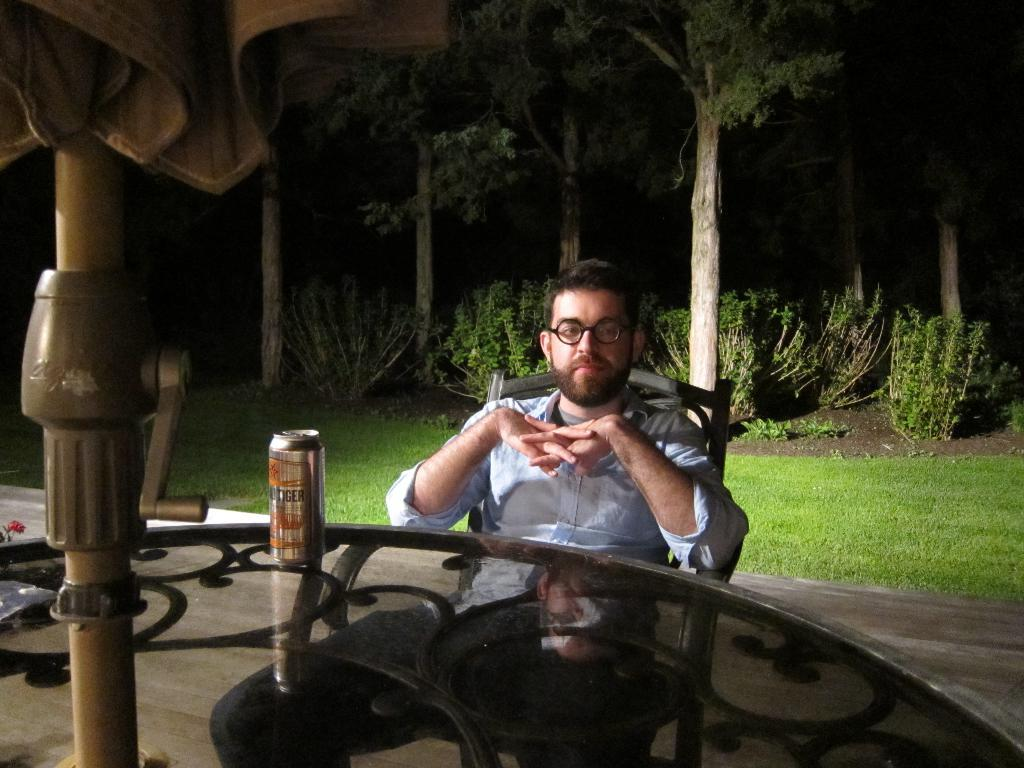Who is present in the image? There is a man in the image. What is the man doing in the image? The man is seated on a chair. What is the man wearing in the image? The man is wearing spectacles. What object is in front of the man? There is a tin in front of the man. What can be seen in the background of the image? There are trees in the background of the image. What type of beam is the man using to make a decision in the image? There is no beam present in the image, nor is the man making any decisions. 